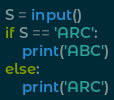<code> <loc_0><loc_0><loc_500><loc_500><_Python_>S = input()
if S == 'ARC':
    print('ABC')
else:
    print('ARC')</code> 